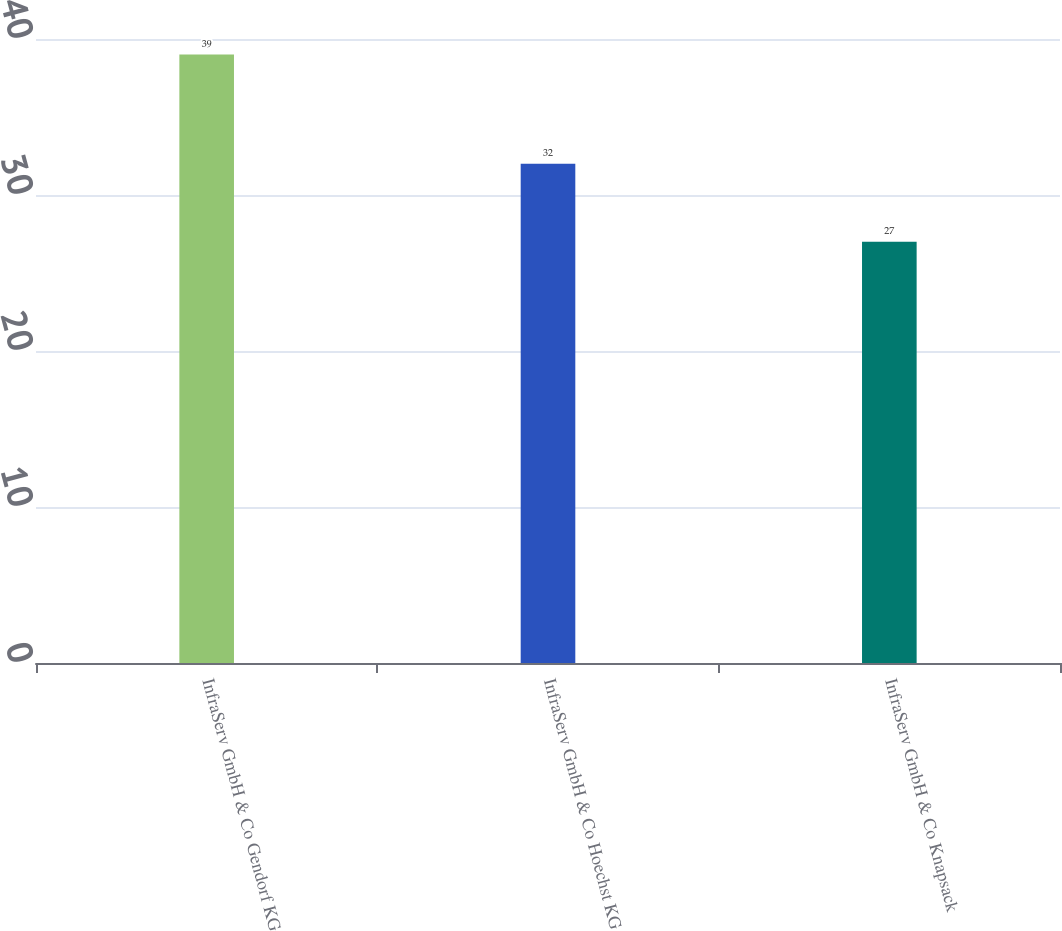Convert chart. <chart><loc_0><loc_0><loc_500><loc_500><bar_chart><fcel>InfraServ GmbH & Co Gendorf KG<fcel>InfraServ GmbH & Co Hoechst KG<fcel>InfraServ GmbH & Co Knapsack<nl><fcel>39<fcel>32<fcel>27<nl></chart> 